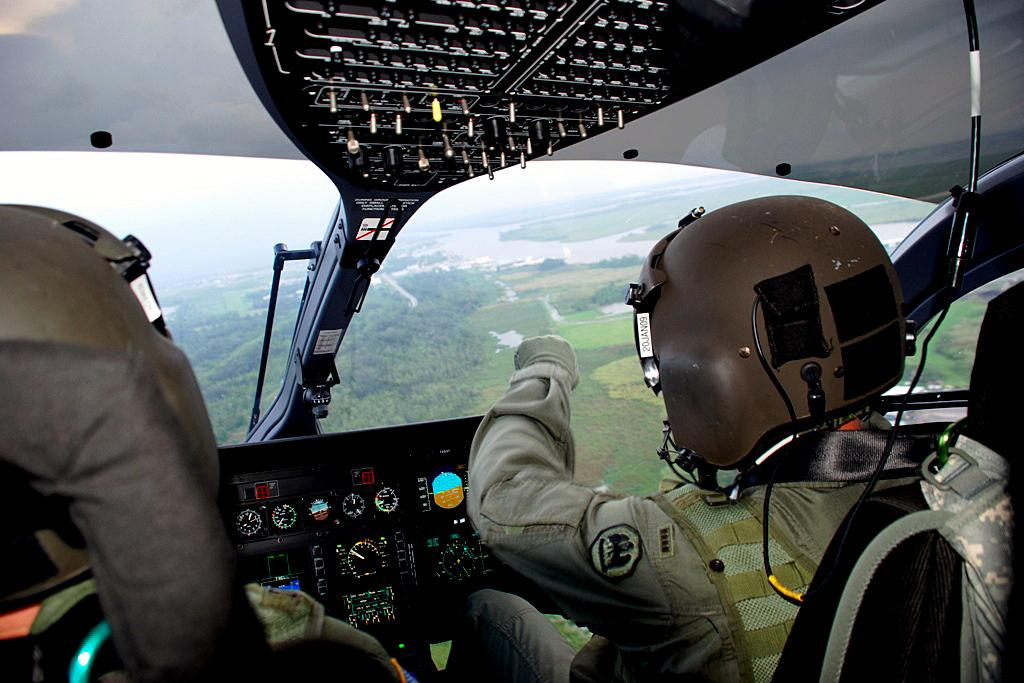What is the person in the image doing? The person is sitting on a chair in the image. Where is the person sitting? The person is inside an airplane. What can be seen at the top of the image? There is a control panel at the top of the image. What can be seen at the bottom of the image? There are speedometers at the bottom of the image. How many apples are on the prison self in the image? There are no apples, prison, or self present in the image. 